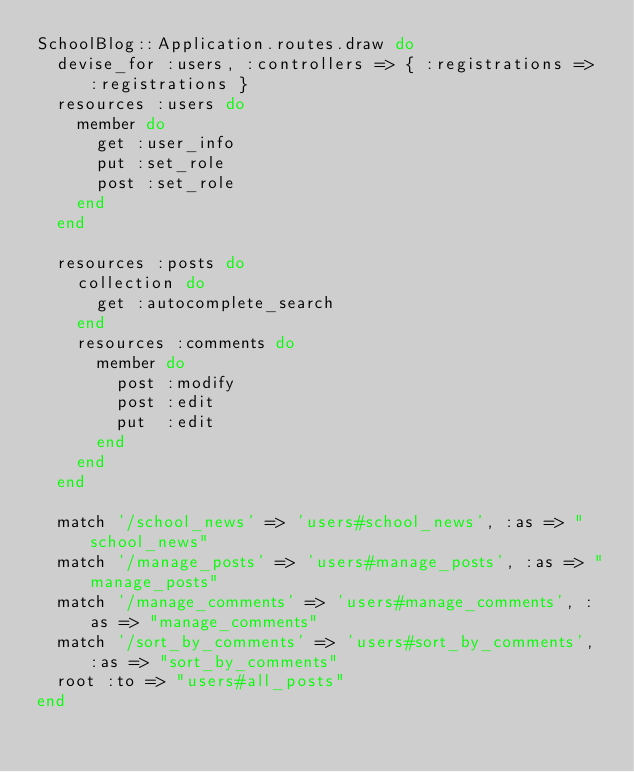<code> <loc_0><loc_0><loc_500><loc_500><_Ruby_>SchoolBlog::Application.routes.draw do
  devise_for :users, :controllers => { :registrations => :registrations }
  resources :users do
    member do
      get :user_info
      put :set_role
      post :set_role
    end
  end

  resources :posts do
    collection do
      get :autocomplete_search
    end
    resources :comments do
      member do
        post :modify
        post :edit
        put  :edit
      end
    end
  end

  match '/school_news' => 'users#school_news', :as => "school_news"
  match '/manage_posts' => 'users#manage_posts', :as => "manage_posts"
  match '/manage_comments' => 'users#manage_comments', :as => "manage_comments"
  match '/sort_by_comments' => 'users#sort_by_comments', :as => "sort_by_comments"
  root :to => "users#all_posts"
end
</code> 